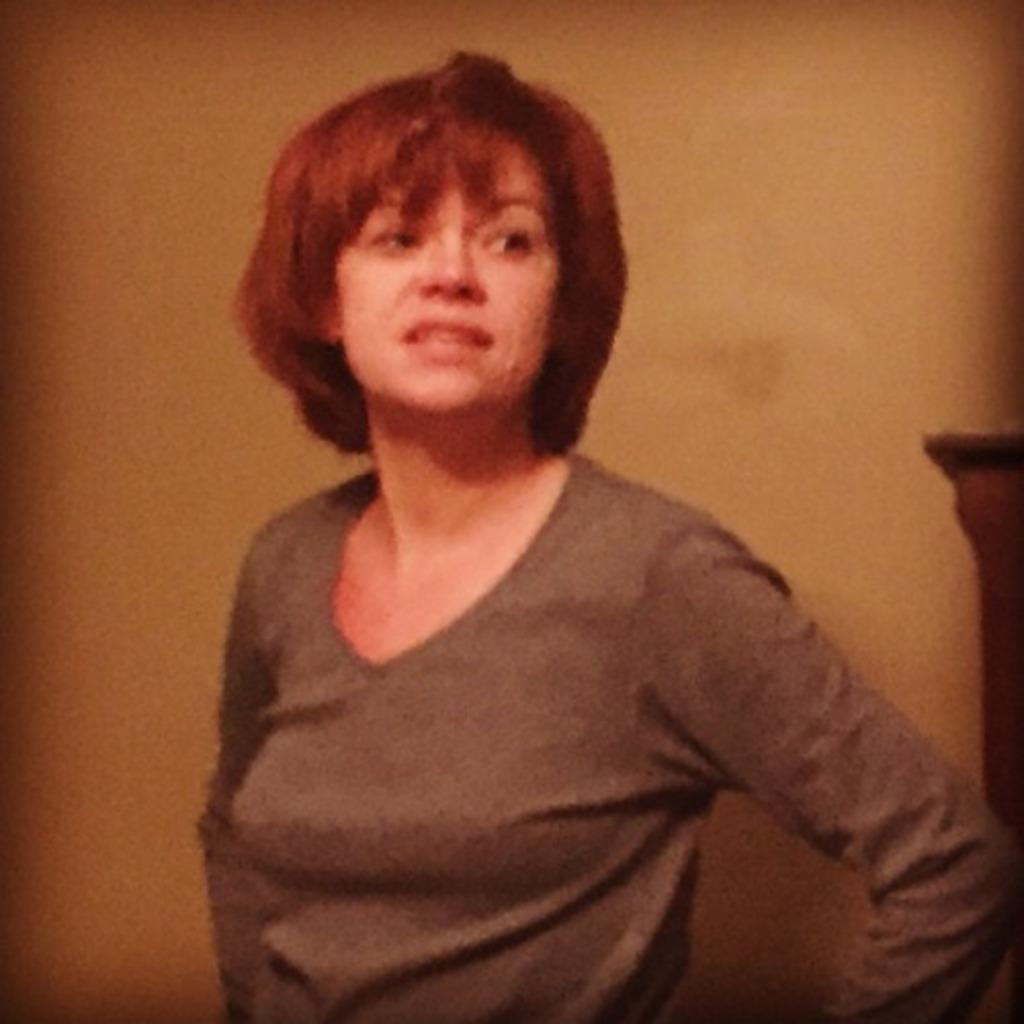Who is the main subject in the image? There is a lady in the image. What is the lady doing in the image? The lady is standing. What is the lady wearing in the image? The lady is wearing a brown t-shirt. What can be seen in the background of the image? There is a wall in the background of the image. What type of iron is the lady using to make the quilt in the image? There is no iron or quilt present in the image; the lady is simply standing and wearing a brown t-shirt. 